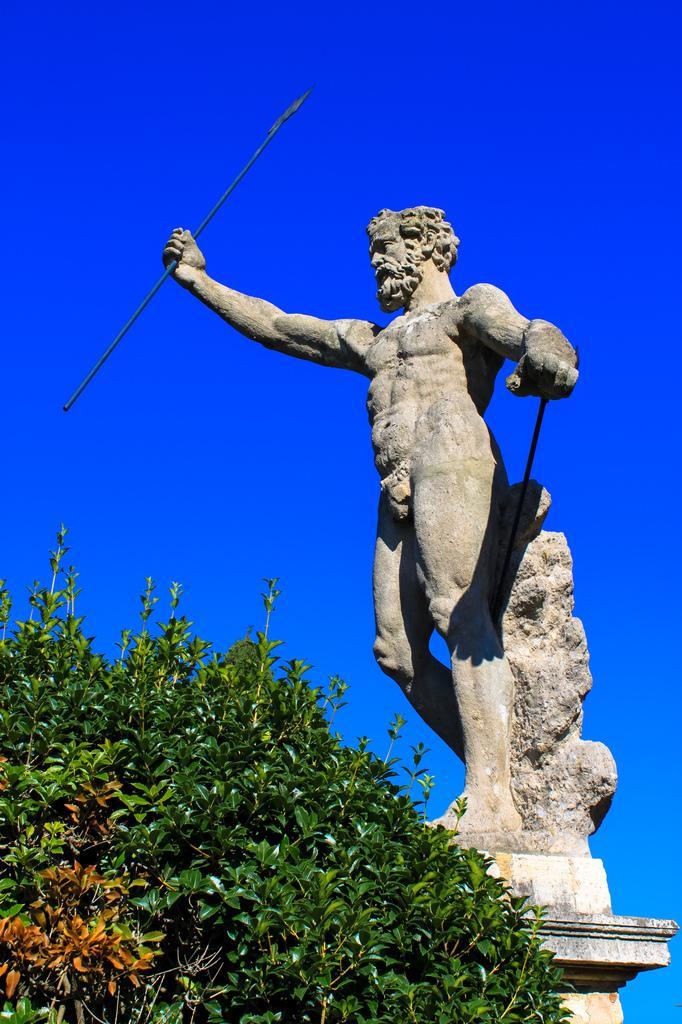Could you give a brief overview of what you see in this image? In this picture there is a statue of a person and there is a plant. At the top there is sky. 